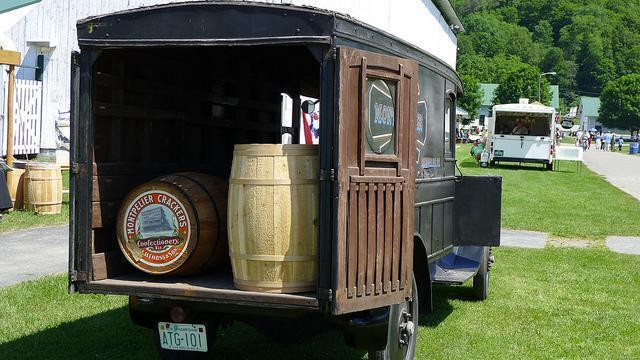What type of labeling is on the barrel?
From the following set of four choices, select the accurate answer to respond to the question.
Options: Brand, regulatory, warning, directional. Brand. 